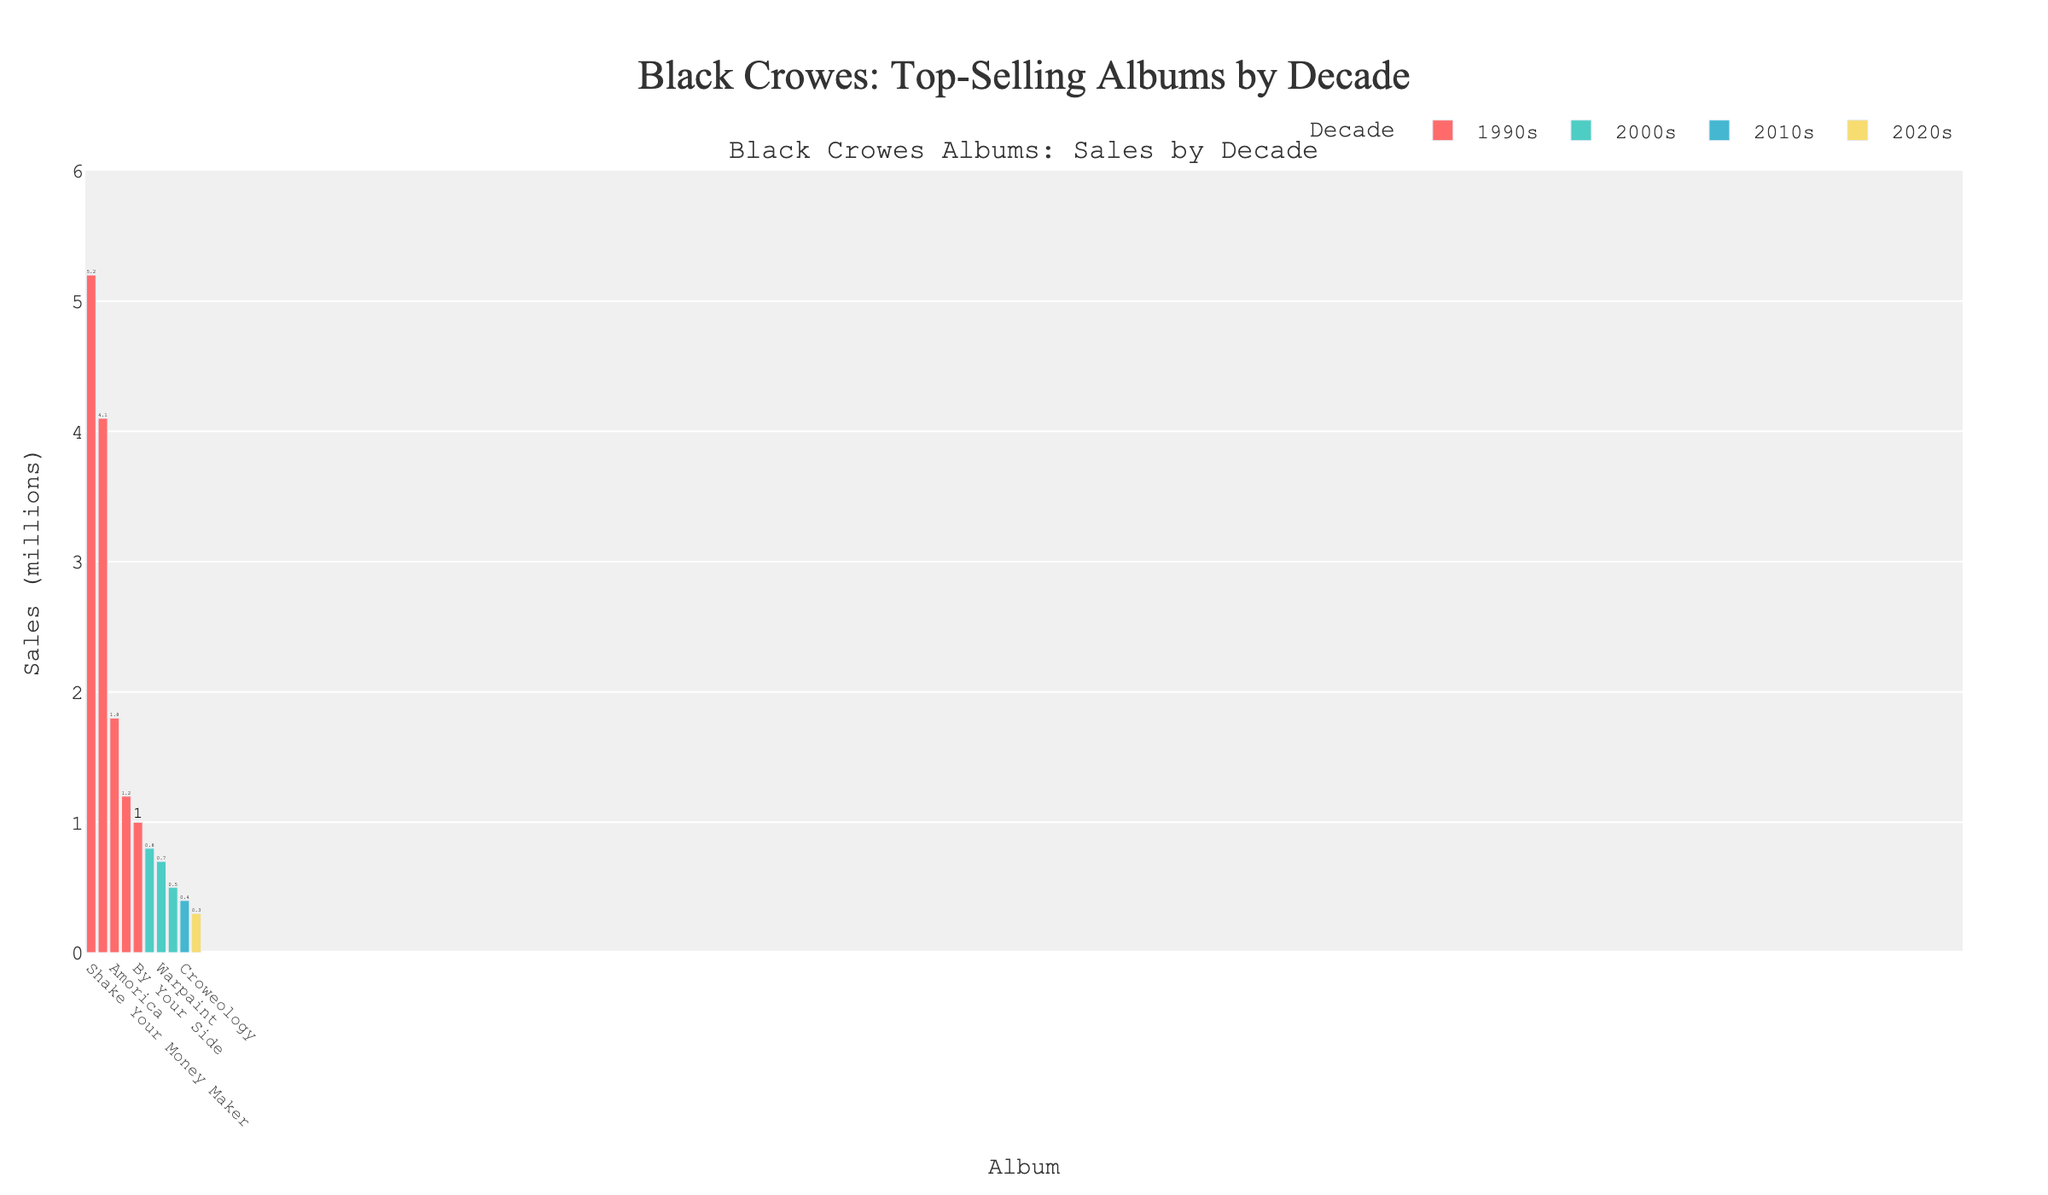Which album has the highest sales in the 1990s? Look at the bars associated with the 1990s and identify the highest one. "Shake Your Money Maker" has the highest bar in the 1990s with 5.2 million sales.
Answer: Shake Your Money Maker How many albums did the Black Crowes release in the 2000s according to the chart? Identify the bars labeled with the 2000s. There are four bars corresponding to "Lions," "Warpaint," "Before the Frost...Until the Freeze," and "Croweology" released in the 2000s.
Answer: 4 What is the total sales of Black Crowes albums in the 1990s? Sum the sales values of all albums from the 1990s. The albums and their sales are: 5.2 + 4.1 + 1.8 + 1.2 + 1.0 = 13.3 million.
Answer: 13.3 million Which decade has the least total album sales? Sum the sales for each decade: 
- 1990s: 13.3 million
- 2000s: 2.0 million
- 2010s: 0.4 million
- 2020s: 0.3 million
The 2020s have the least total album sales.
Answer: 2020s Which album had the lowest sales in the 1990s? Look at the bars for the 1990s and identify the shortest one. "By Your Side" has the lowest sales with 1.0 million.
Answer: By Your Side What is the difference in sales between "Shake Your Money Maker" and "The Southern Harmony and Musical Companion"? Subtract the sales of "The Southern Harmony and Musical Companion" from "Shake Your Money Maker." The sales are 5.2 million for "Shake Your Money Maker" and 4.1 million for "The Southern Harmony and Musical Companion." 5.2 - 4.1 = 1.1 million.
Answer: 1.1 million Which decade shows the most diversity in album colors in the chart? Each decade has a unique color, so diversity here means a variety of albums and their corresponding colors within a decade. The 1990s have five different albums with a unique color for each, indicating the highest diversity.
Answer: 1990s What's the average sales of the albums released in the 2000s? Calculate the mean sales for albums from the 2000s. The sales are 0.8, 0.7, 0.5, and 0.4 million. The average is (0.8 + 0.7 + 0.5 + 0.4) / 4 = 0.6 million.
Answer: 0.6 million 